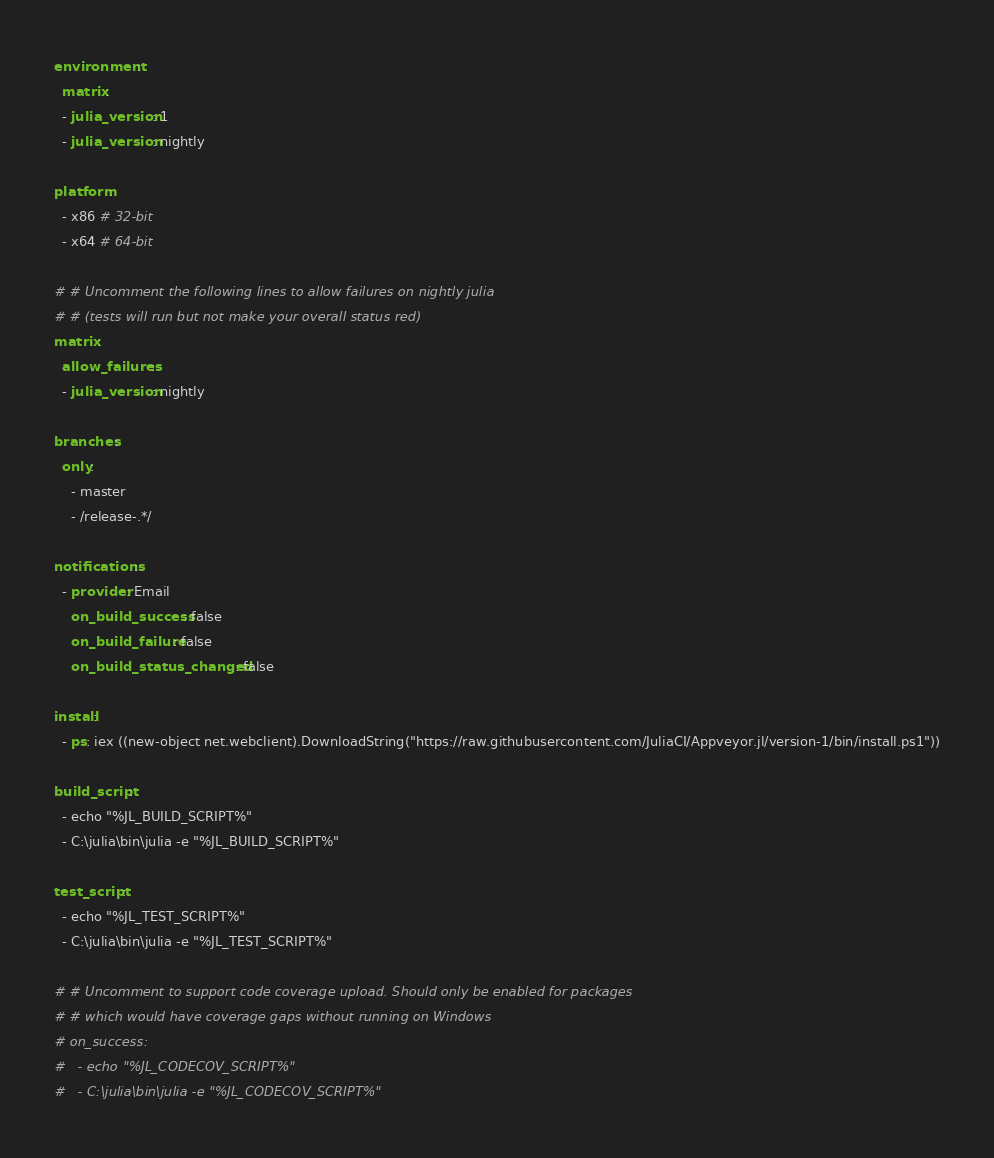Convert code to text. <code><loc_0><loc_0><loc_500><loc_500><_YAML_>environment:
  matrix:
  - julia_version: 1
  - julia_version: nightly

platform:
  - x86 # 32-bit
  - x64 # 64-bit

# # Uncomment the following lines to allow failures on nightly julia
# # (tests will run but not make your overall status red)
matrix:
  allow_failures:
  - julia_version: nightly

branches:
  only:
    - master
    - /release-.*/

notifications:
  - provider: Email
    on_build_success: false
    on_build_failure: false
    on_build_status_changed: false

install:
  - ps: iex ((new-object net.webclient).DownloadString("https://raw.githubusercontent.com/JuliaCI/Appveyor.jl/version-1/bin/install.ps1"))

build_script:
  - echo "%JL_BUILD_SCRIPT%"
  - C:\julia\bin\julia -e "%JL_BUILD_SCRIPT%"

test_script:
  - echo "%JL_TEST_SCRIPT%"
  - C:\julia\bin\julia -e "%JL_TEST_SCRIPT%"

# # Uncomment to support code coverage upload. Should only be enabled for packages
# # which would have coverage gaps without running on Windows
# on_success:
#   - echo "%JL_CODECOV_SCRIPT%"
#   - C:\julia\bin\julia -e "%JL_CODECOV_SCRIPT%"
</code> 